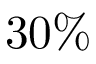<formula> <loc_0><loc_0><loc_500><loc_500>3 0 \%</formula> 